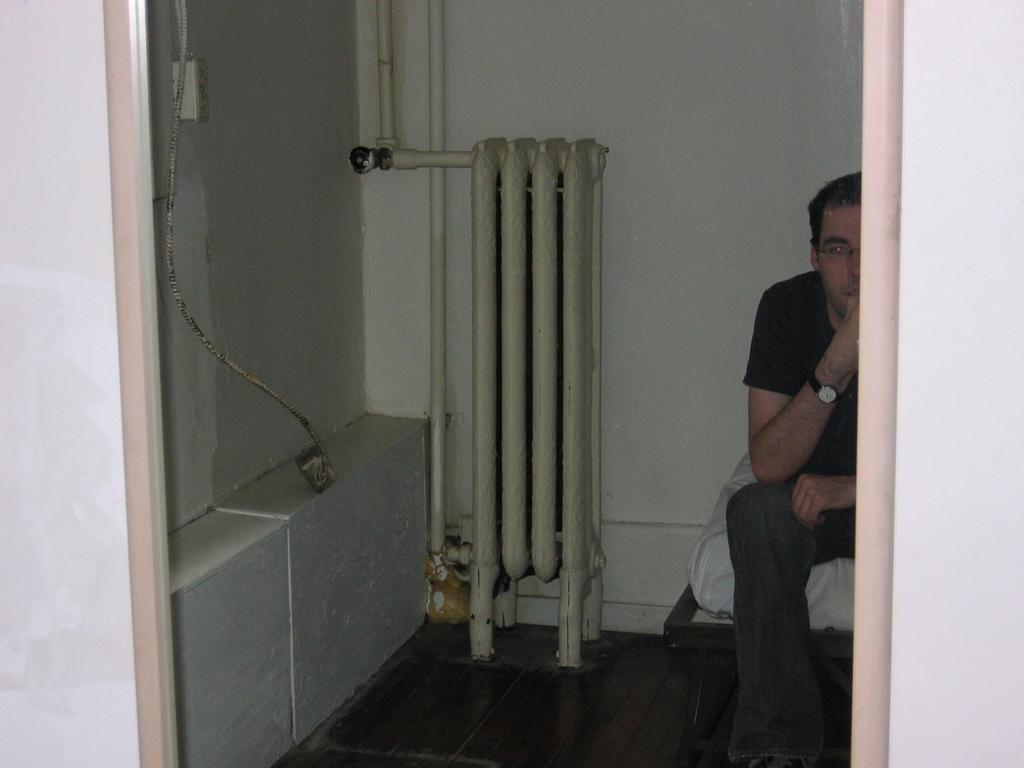How would you summarize this image in a sentence or two? In the image there is a man in black t-shirt sitting on bed, on the left side there are pipes in front of the wall. 